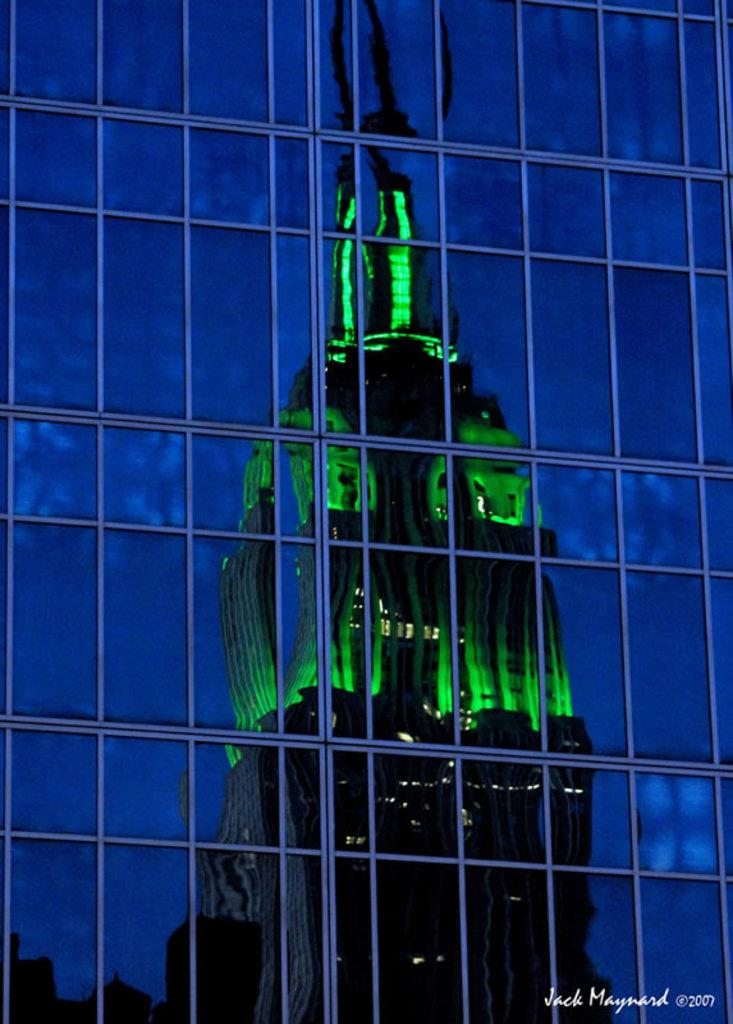What type of material is used for the windows in the image? The windows in the image are made of glass. What can be seen through the glass windows? There is a building visible behind the glass windows. How many arms are visible in the image? There are no arms visible in the image, as it only features glass windows and a building in the background. 